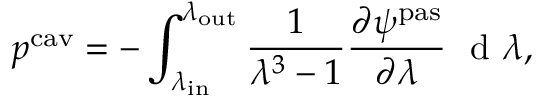<formula> <loc_0><loc_0><loc_500><loc_500>p ^ { c a v } = - \int _ { \lambda _ { i n } } ^ { \lambda _ { o u t } } \frac { 1 } { \lambda ^ { 3 } - 1 } \frac { \partial \psi ^ { p a s } } { \partial \lambda } \ d \lambda ,</formula> 